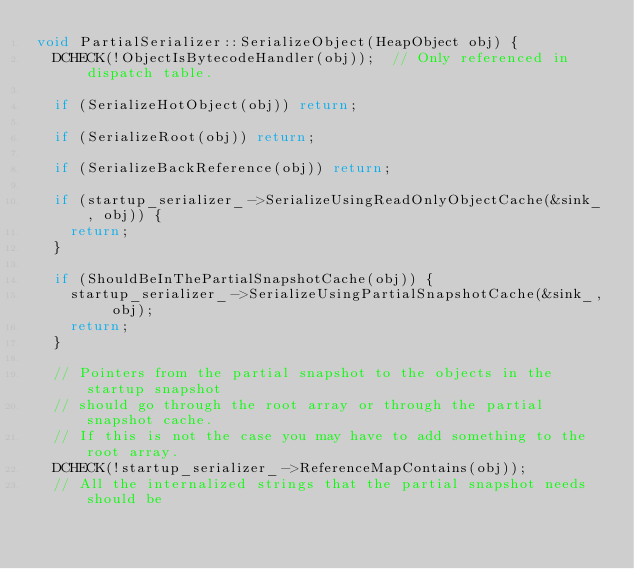Convert code to text. <code><loc_0><loc_0><loc_500><loc_500><_C++_>void PartialSerializer::SerializeObject(HeapObject obj) {
  DCHECK(!ObjectIsBytecodeHandler(obj));  // Only referenced in dispatch table.

  if (SerializeHotObject(obj)) return;

  if (SerializeRoot(obj)) return;

  if (SerializeBackReference(obj)) return;

  if (startup_serializer_->SerializeUsingReadOnlyObjectCache(&sink_, obj)) {
    return;
  }

  if (ShouldBeInThePartialSnapshotCache(obj)) {
    startup_serializer_->SerializeUsingPartialSnapshotCache(&sink_, obj);
    return;
  }

  // Pointers from the partial snapshot to the objects in the startup snapshot
  // should go through the root array or through the partial snapshot cache.
  // If this is not the case you may have to add something to the root array.
  DCHECK(!startup_serializer_->ReferenceMapContains(obj));
  // All the internalized strings that the partial snapshot needs should be</code> 